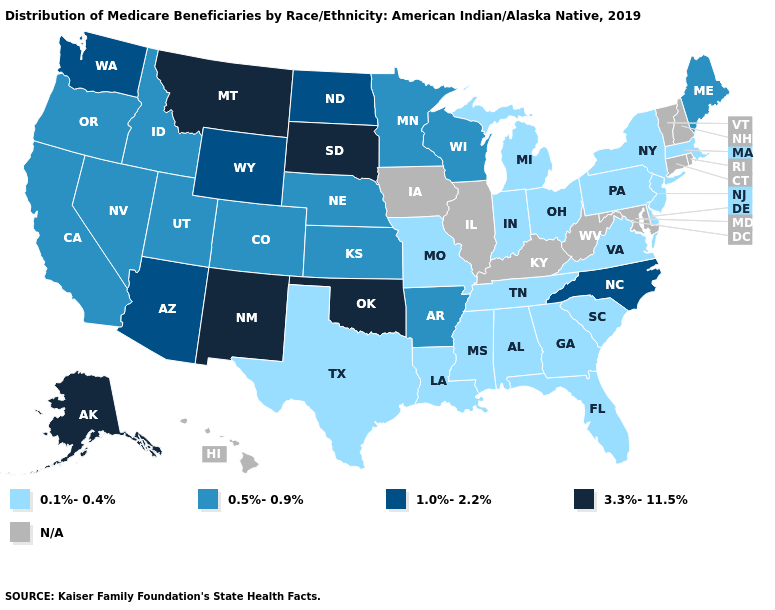Does the first symbol in the legend represent the smallest category?
Answer briefly. Yes. What is the value of Nevada?
Be succinct. 0.5%-0.9%. Does Oregon have the highest value in the USA?
Answer briefly. No. What is the lowest value in the West?
Write a very short answer. 0.5%-0.9%. Is the legend a continuous bar?
Keep it brief. No. Does Kansas have the lowest value in the MidWest?
Concise answer only. No. Name the states that have a value in the range 3.3%-11.5%?
Give a very brief answer. Alaska, Montana, New Mexico, Oklahoma, South Dakota. Does Ohio have the highest value in the USA?
Write a very short answer. No. Name the states that have a value in the range 3.3%-11.5%?
Be succinct. Alaska, Montana, New Mexico, Oklahoma, South Dakota. Name the states that have a value in the range N/A?
Keep it brief. Connecticut, Hawaii, Illinois, Iowa, Kentucky, Maryland, New Hampshire, Rhode Island, Vermont, West Virginia. Name the states that have a value in the range 3.3%-11.5%?
Give a very brief answer. Alaska, Montana, New Mexico, Oklahoma, South Dakota. Does the first symbol in the legend represent the smallest category?
Answer briefly. Yes. 